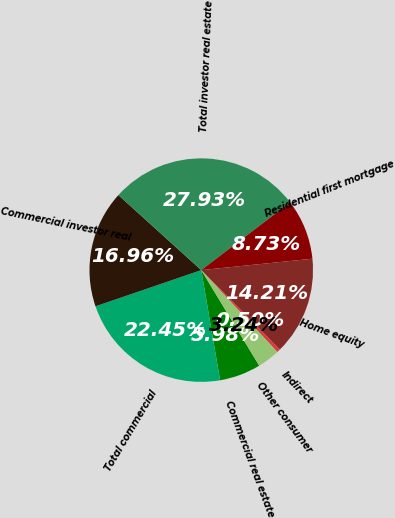Convert chart. <chart><loc_0><loc_0><loc_500><loc_500><pie_chart><fcel>Commercial real estate<fcel>Total commercial<fcel>Commercial investor real<fcel>Total investor real estate<fcel>Residential first mortgage<fcel>Home equity<fcel>Indirect<fcel>Other consumer<nl><fcel>5.98%<fcel>22.45%<fcel>16.96%<fcel>27.93%<fcel>8.73%<fcel>14.21%<fcel>0.5%<fcel>3.24%<nl></chart> 